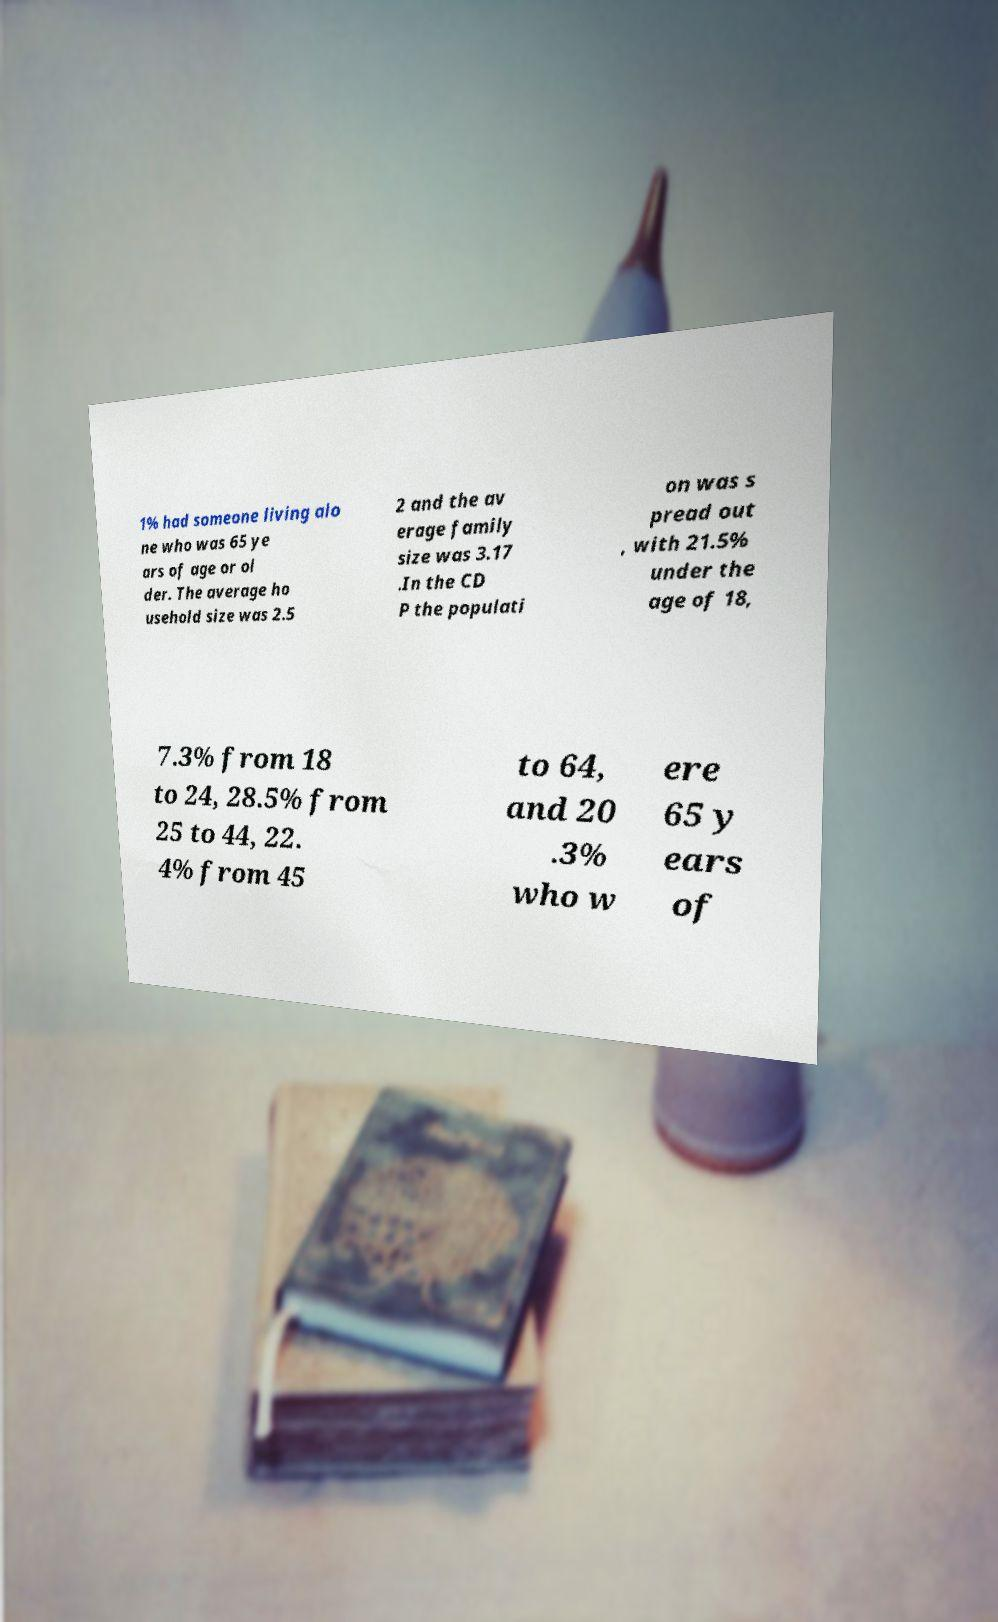Could you extract and type out the text from this image? 1% had someone living alo ne who was 65 ye ars of age or ol der. The average ho usehold size was 2.5 2 and the av erage family size was 3.17 .In the CD P the populati on was s pread out , with 21.5% under the age of 18, 7.3% from 18 to 24, 28.5% from 25 to 44, 22. 4% from 45 to 64, and 20 .3% who w ere 65 y ears of 